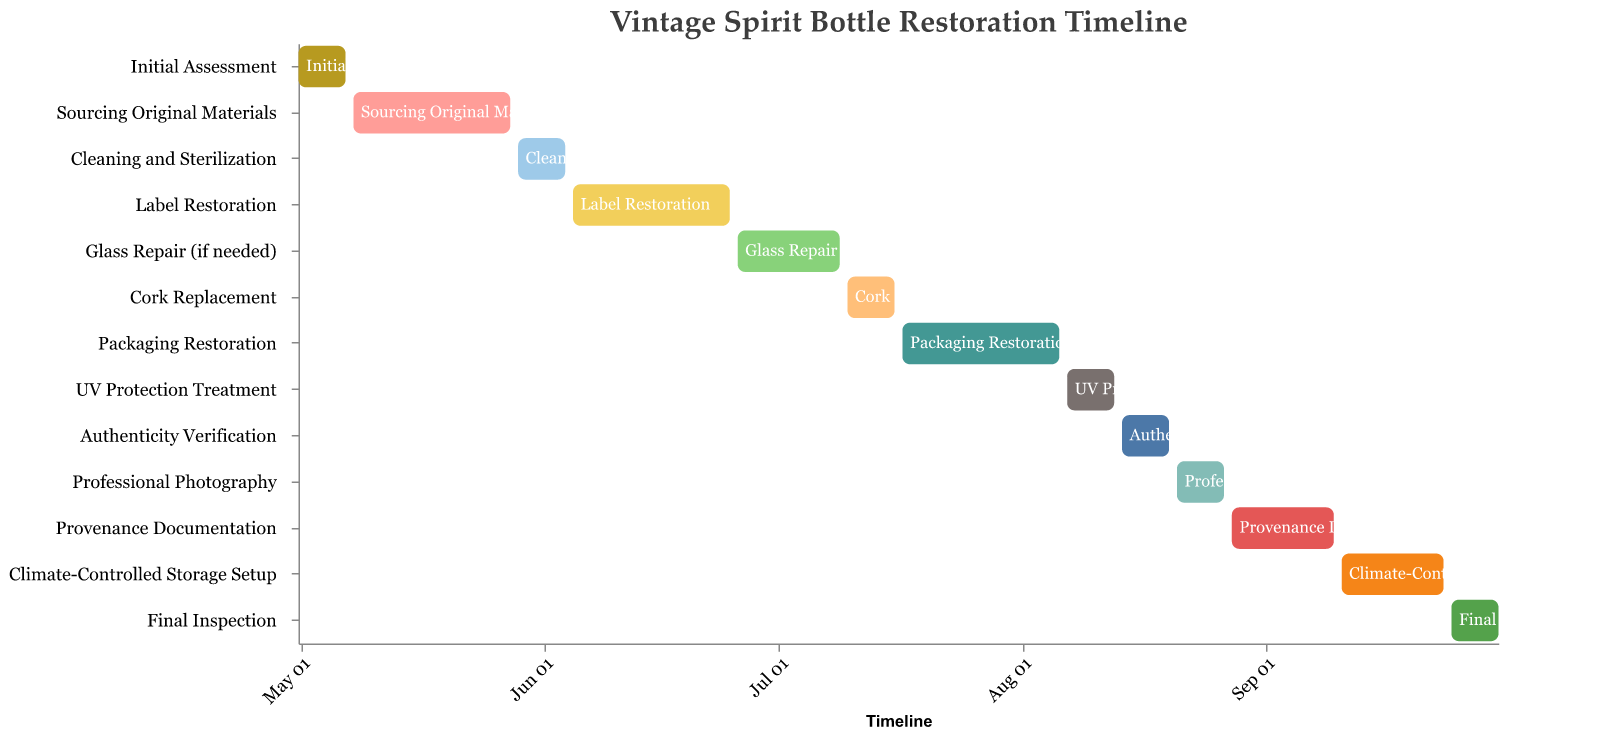What's the title of the figure? The title is located at the top of the chart and is usually written in a larger font size.
Answer: Vintage Spirit Bottle Restoration Timeline What is the first task listed in the restoration timeline? The tasks are listed on the y-axis, the first one can be found by looking at the top of the list.
Answer: Initial Assessment How long is the "Label Restoration" task? Locate "Label Restoration" on the y-axis and observe its start and end dates on the x-axis, which are June 5 and June 25 respectively. The duration is (25 - 5 + 1) days.
Answer: 21 days When does the "Glass Repair (if needed)" task end? Locate "Glass Repair (if needed)" on the y-axis and follow to its corresponding end date on the x-axis.
Answer: July 9, 2023 Which task takes place immediately before "UV Protection Treatment"? Locate "UV Protection Treatment" on the y-axis and look directly above it for the previous task.
Answer: Packaging Restoration What is the cumulative duration of the first three tasks? Sum the durations of the first three tasks by calculating the difference between start and end dates for each: (7 - 1 + 1) + (28 - 8 + 1) + (4 - 29 + 1).
Answer: 35 days Which task has the shortest duration? Compare the task durations by observing the lengths of the bars; the shortest bar indicates the shortest duration.
Answer: Cork Replacement Do any tasks overlap with the "Final Inspection"? Determine the range of dates for "Final Inspection" and check if any other tasks have overlapping dates within this range.
Answer: No tasks overlap Which two tasks start in July? Look at the x-axis for tasks starting in July and identify them.
Answer: Glass Repair (if needed) and Cork Replacement Which task directly follows the "Professional Photography"? Locate "Professional Photography" and find the task immediately below it on the y-axis.
Answer: Provenance Documentation 